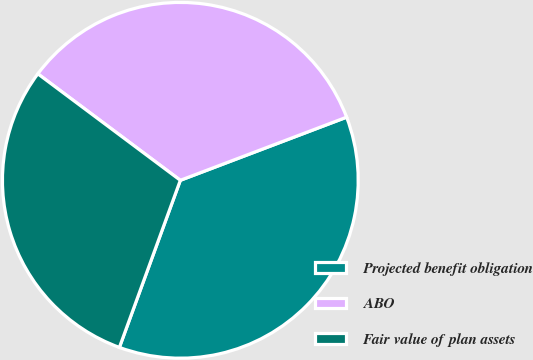<chart> <loc_0><loc_0><loc_500><loc_500><pie_chart><fcel>Projected benefit obligation<fcel>ABO<fcel>Fair value of plan assets<nl><fcel>36.34%<fcel>34.01%<fcel>29.65%<nl></chart> 